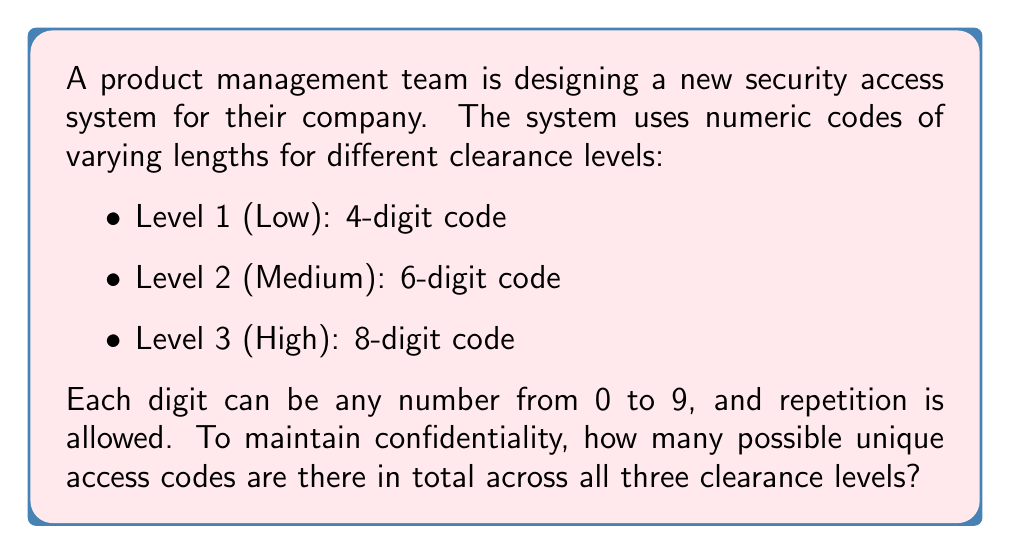Can you solve this math problem? Let's break this down step-by-step:

1) For Level 1 (4-digit code):
   - Each digit has 10 possible choices (0-9)
   - We have 4 positions to fill
   - This is a case of replacement with repetition allowed
   - Number of possibilities = $10^4$

2) For Level 2 (6-digit code):
   - Each digit has 10 possible choices (0-9)
   - We have 6 positions to fill
   - Number of possibilities = $10^6$

3) For Level 3 (8-digit code):
   - Each digit has 10 possible choices (0-9)
   - We have 8 positions to fill
   - Number of possibilities = $10^8$

4) To find the total number of possible codes across all levels, we sum the possibilities for each level:

   Total = Level 1 + Level 2 + Level 3
   $$ \text{Total} = 10^4 + 10^6 + 10^8 $$

5) Let's calculate:
   $$ \begin{align*}
   \text{Total} &= 10,000 + 1,000,000 + 100,000,000 \\
   &= 101,010,000
   \end{align*} $$

Therefore, there are 101,010,000 possible unique access codes across all three clearance levels.
Answer: 101,010,000 